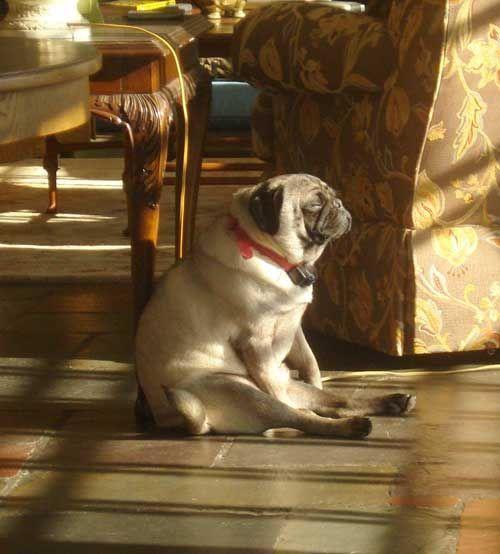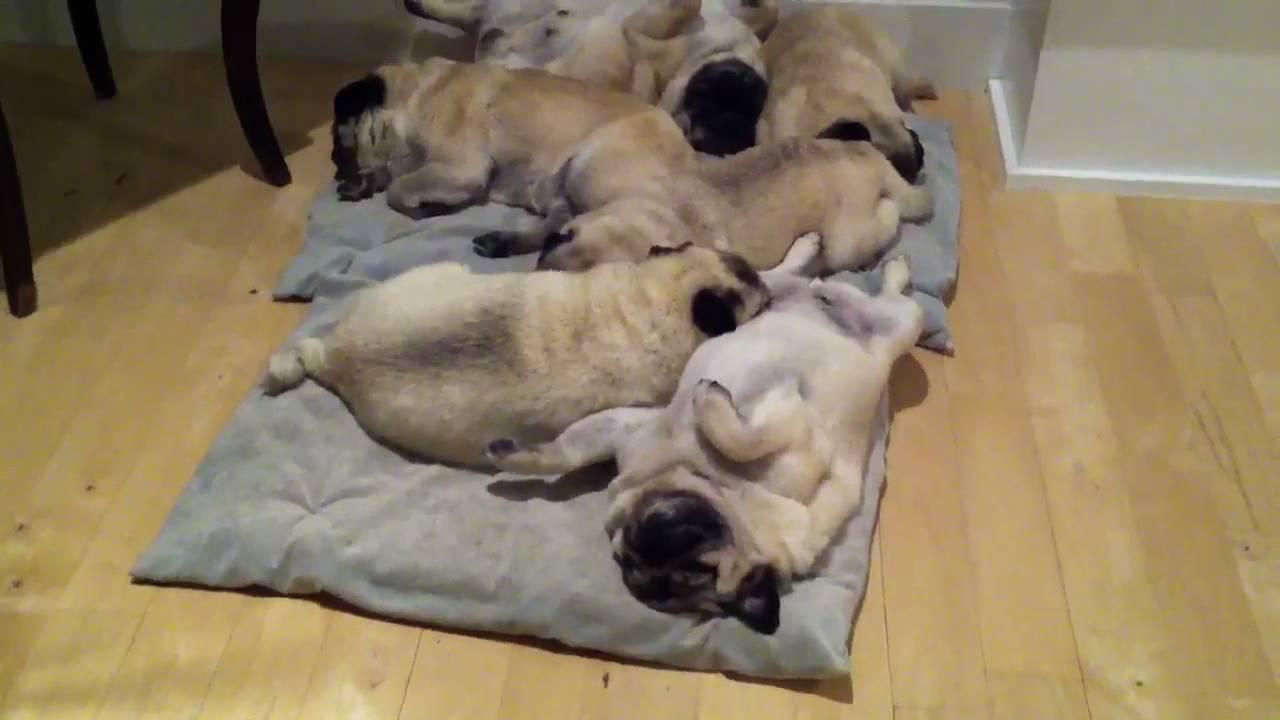The first image is the image on the left, the second image is the image on the right. For the images displayed, is the sentence "An image shows exactly one living pug that is sitting." factually correct? Answer yes or no. Yes. The first image is the image on the left, the second image is the image on the right. Considering the images on both sides, is "there is exactly one dog in the image on the left" valid? Answer yes or no. Yes. 